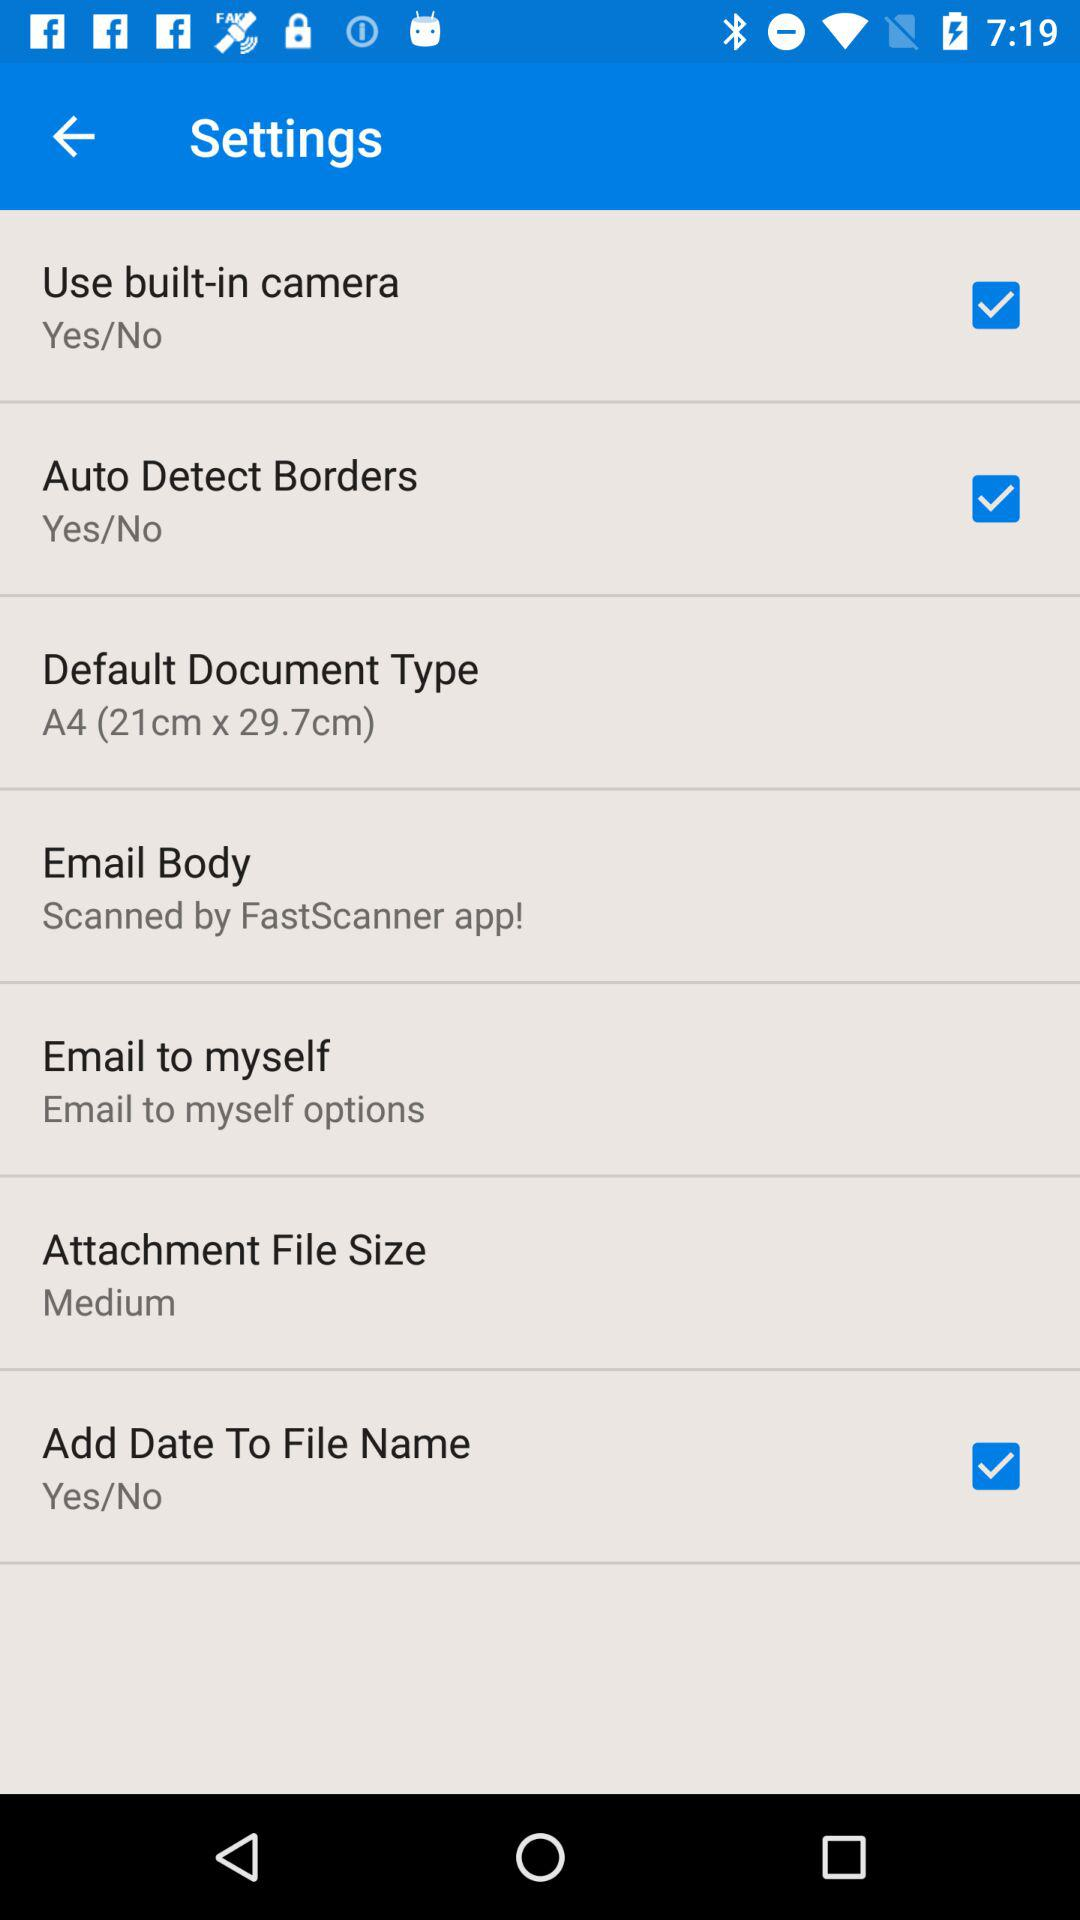What is the status of "Auto Detect Borders"? The status is "on". 